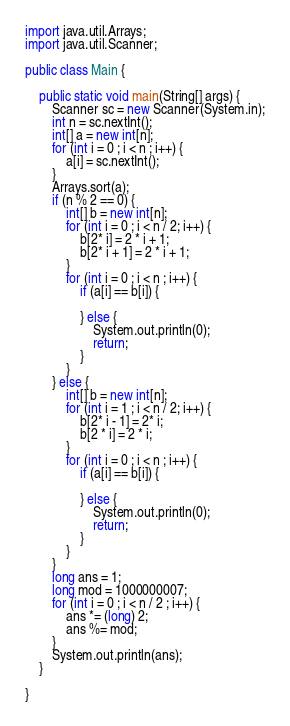<code> <loc_0><loc_0><loc_500><loc_500><_Java_>import java.util.Arrays;
import java.util.Scanner;

public class Main {

    public static void main(String[] args) {
        Scanner sc = new Scanner(System.in);
        int n = sc.nextInt();
        int[] a = new int[n];
        for (int i = 0 ; i < n ; i++) {
            a[i] = sc.nextInt();
        }
        Arrays.sort(a);
        if (n % 2 == 0) {
            int[] b = new int[n];
            for (int i = 0 ; i < n / 2; i++) {
                b[2* i] = 2 * i + 1;
                b[2* i + 1] = 2 * i + 1;
            }
            for (int i = 0 ; i < n ; i++) {
                if (a[i] == b[i]) {

                } else {
                    System.out.println(0);
                    return;
                }
            }
        } else {
            int[] b = new int[n];
            for (int i = 1 ; i < n / 2; i++) {
                b[2* i - 1] = 2* i;
                b[2 * i] = 2 * i;
            }
            for (int i = 0 ; i < n ; i++) {
                if (a[i] == b[i]) {

                } else {
                    System.out.println(0);
                    return;
                }
            }
        }
        long ans = 1;
        long mod = 1000000007;
        for (int i = 0 ; i < n / 2 ; i++) {
            ans *= (long) 2;
            ans %= mod;
        }
        System.out.println(ans);
    }

}
</code> 